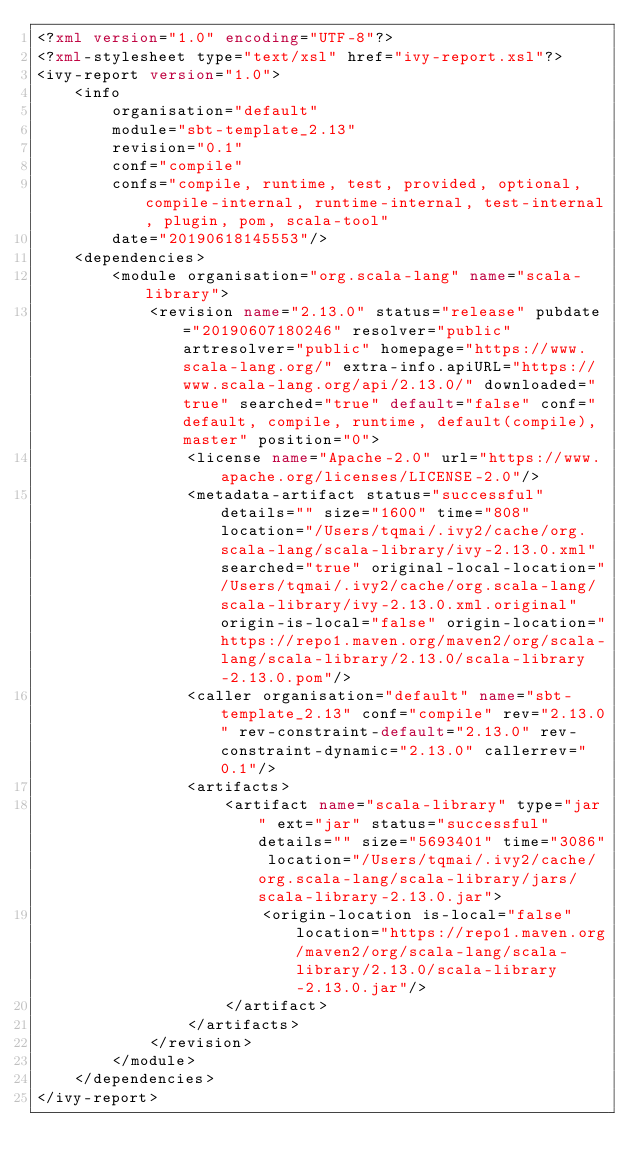<code> <loc_0><loc_0><loc_500><loc_500><_XML_><?xml version="1.0" encoding="UTF-8"?>
<?xml-stylesheet type="text/xsl" href="ivy-report.xsl"?>
<ivy-report version="1.0">
	<info
		organisation="default"
		module="sbt-template_2.13"
		revision="0.1"
		conf="compile"
		confs="compile, runtime, test, provided, optional, compile-internal, runtime-internal, test-internal, plugin, pom, scala-tool"
		date="20190618145553"/>
	<dependencies>
		<module organisation="org.scala-lang" name="scala-library">
			<revision name="2.13.0" status="release" pubdate="20190607180246" resolver="public" artresolver="public" homepage="https://www.scala-lang.org/" extra-info.apiURL="https://www.scala-lang.org/api/2.13.0/" downloaded="true" searched="true" default="false" conf="default, compile, runtime, default(compile), master" position="0">
				<license name="Apache-2.0" url="https://www.apache.org/licenses/LICENSE-2.0"/>
				<metadata-artifact status="successful" details="" size="1600" time="808" location="/Users/tqmai/.ivy2/cache/org.scala-lang/scala-library/ivy-2.13.0.xml" searched="true" original-local-location="/Users/tqmai/.ivy2/cache/org.scala-lang/scala-library/ivy-2.13.0.xml.original" origin-is-local="false" origin-location="https://repo1.maven.org/maven2/org/scala-lang/scala-library/2.13.0/scala-library-2.13.0.pom"/>
				<caller organisation="default" name="sbt-template_2.13" conf="compile" rev="2.13.0" rev-constraint-default="2.13.0" rev-constraint-dynamic="2.13.0" callerrev="0.1"/>
				<artifacts>
					<artifact name="scala-library" type="jar" ext="jar" status="successful" details="" size="5693401" time="3086" location="/Users/tqmai/.ivy2/cache/org.scala-lang/scala-library/jars/scala-library-2.13.0.jar">
						<origin-location is-local="false" location="https://repo1.maven.org/maven2/org/scala-lang/scala-library/2.13.0/scala-library-2.13.0.jar"/>
					</artifact>
				</artifacts>
			</revision>
		</module>
	</dependencies>
</ivy-report>
</code> 